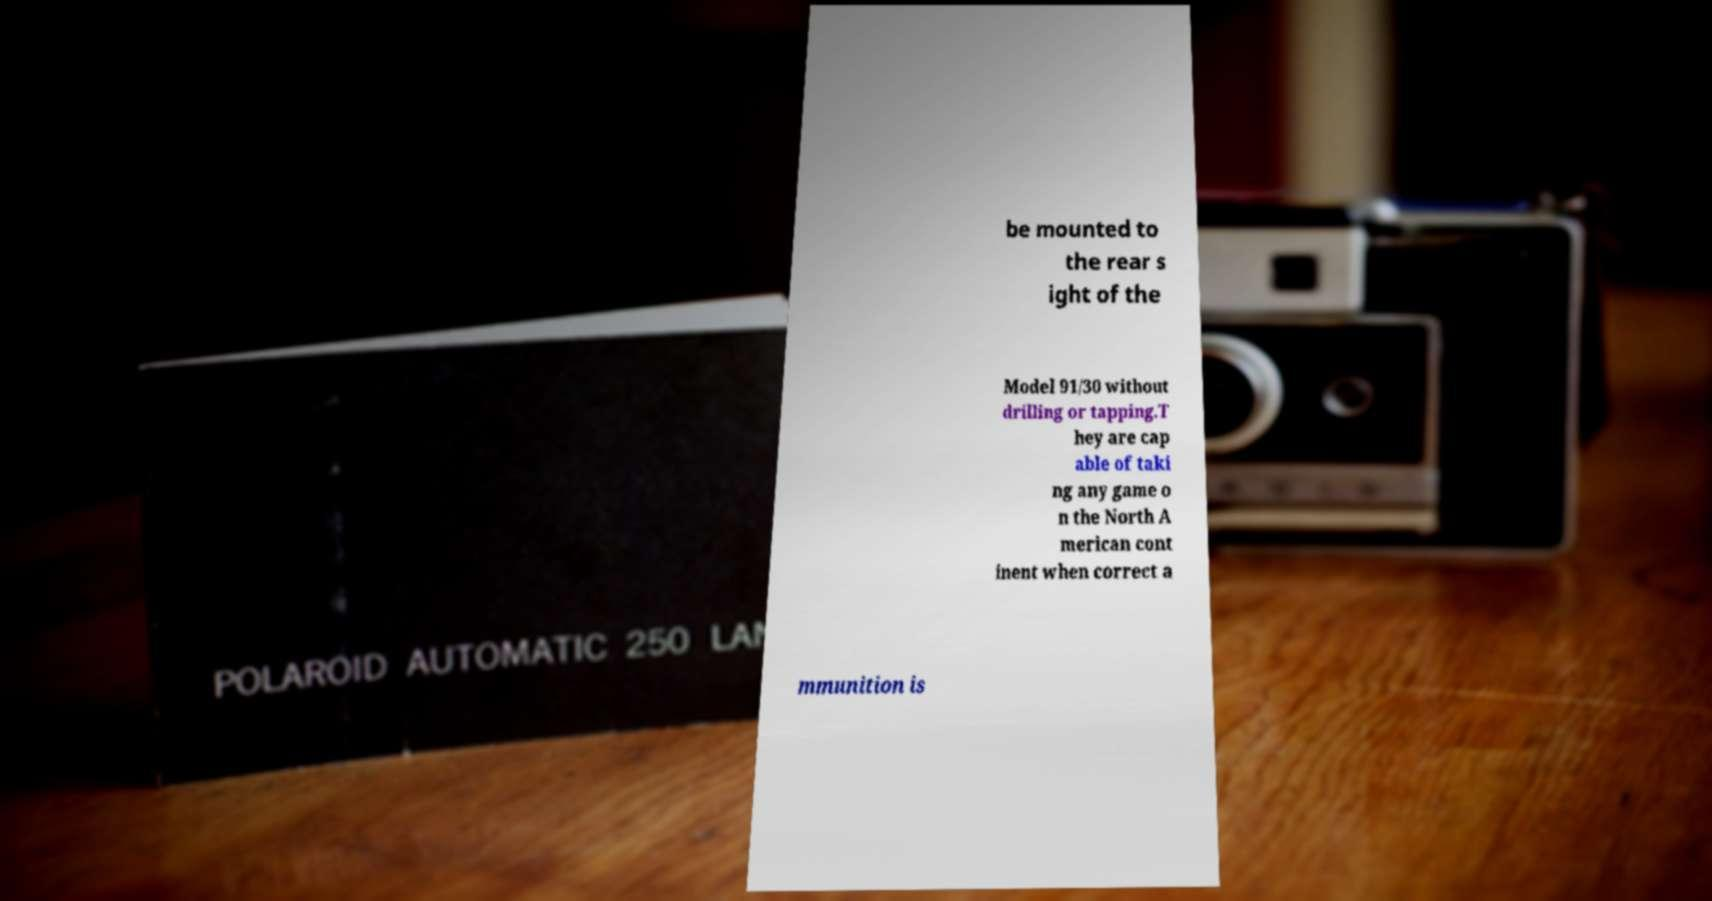Could you extract and type out the text from this image? be mounted to the rear s ight of the Model 91/30 without drilling or tapping.T hey are cap able of taki ng any game o n the North A merican cont inent when correct a mmunition is 